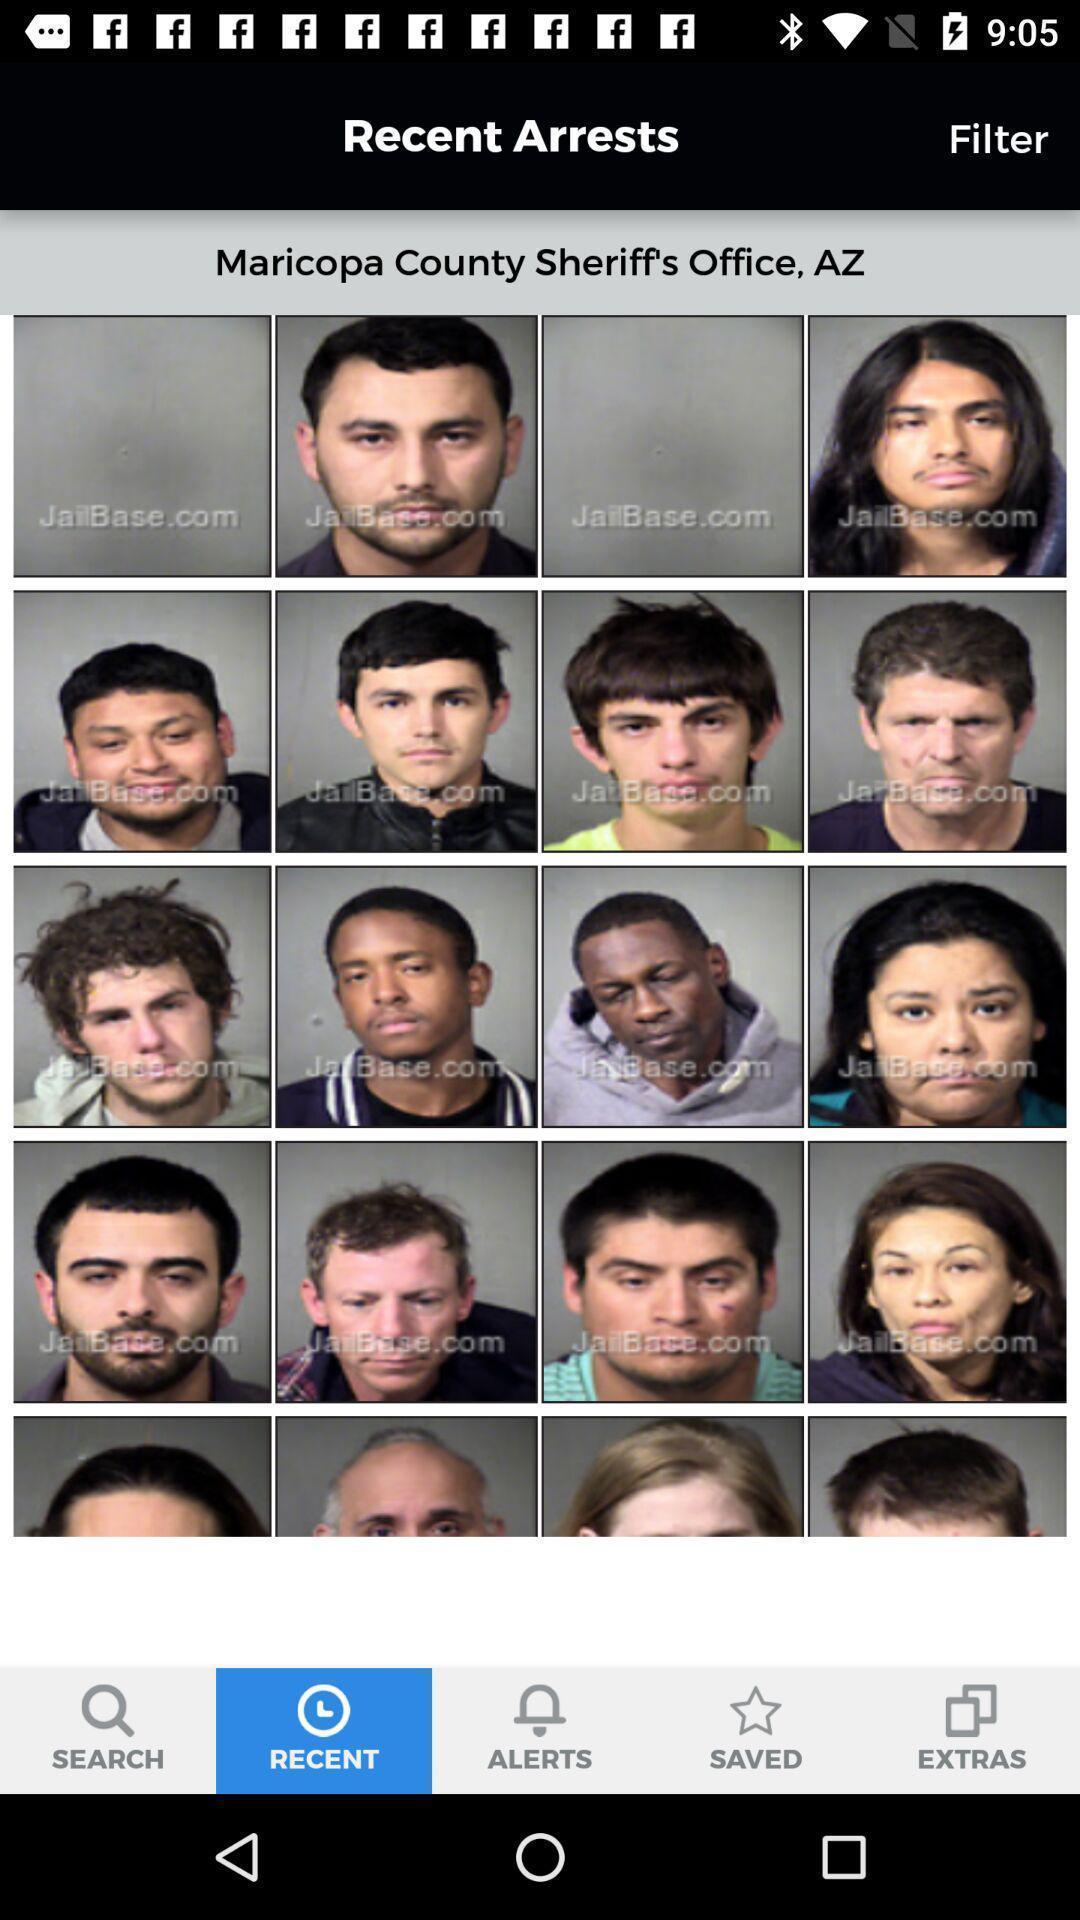What can you discern from this picture? Page shows about the people who got arrested. 